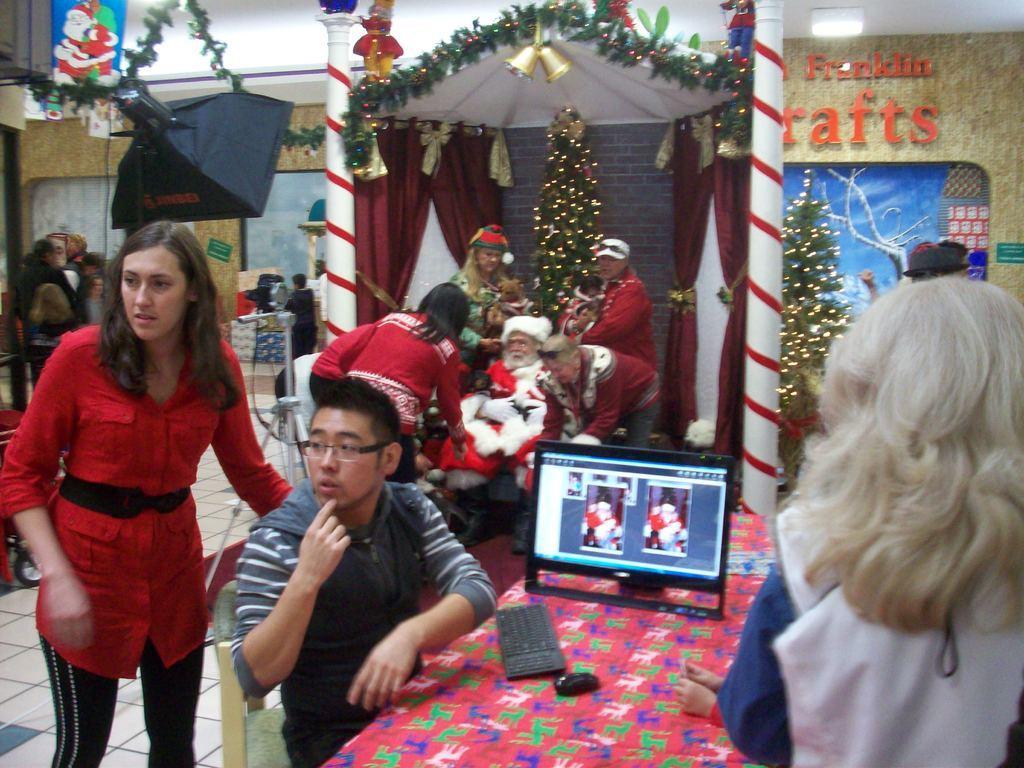How would you summarize this image in a sentence or two? Above this table there is a mouse, keyboard and monitor. Here we can see people, decorative objects, bells, Christmas trees, curtains and lights. This person wore Santa dress. Painting is on the wall. This is tile floor. Here we can see a camera. 